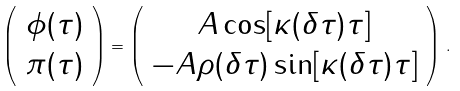Convert formula to latex. <formula><loc_0><loc_0><loc_500><loc_500>\left ( \begin{array} { c } \phi ( \tau ) \\ \pi ( \tau ) \end{array} \right ) = \left ( \begin{array} { c } A \cos [ \kappa ( \delta \tau ) \tau ] \\ - A \rho ( \delta \tau ) \sin [ \kappa ( \delta \tau ) \tau ] \end{array} \right ) \, .</formula> 